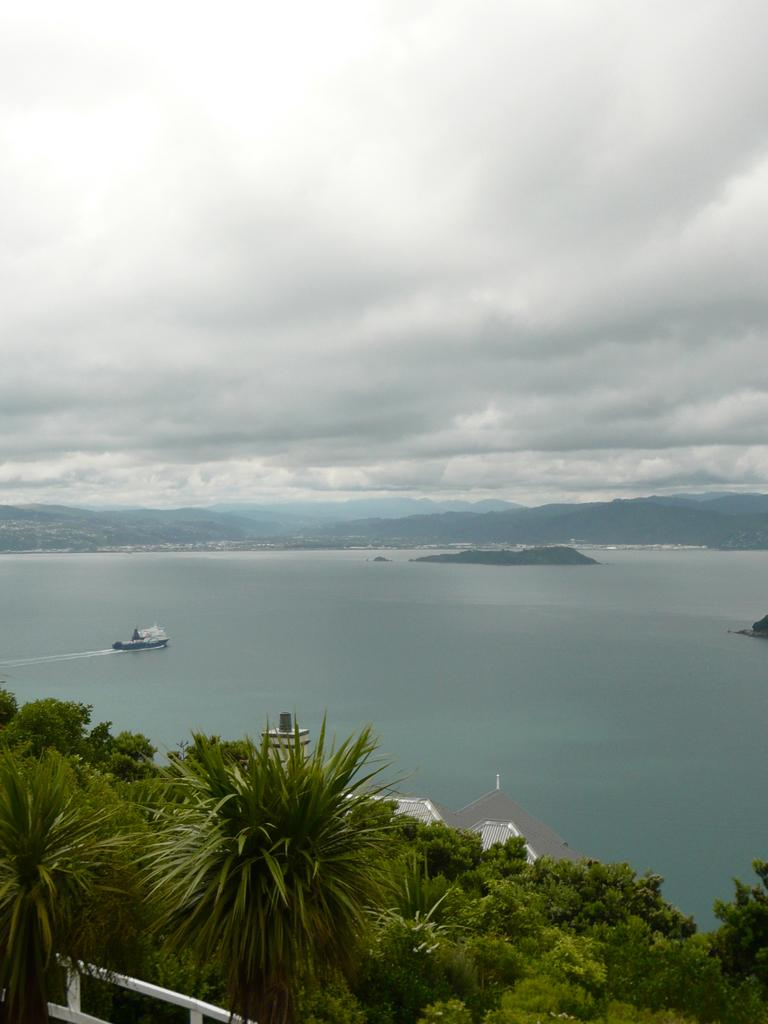What is the main subject of the image? The main subject of the image is a boat. Where is the boat located? The boat is on the water. What other natural elements can be seen in the image? There are trees and mountains visible in the image. What is visible in the background of the image? The sky is visible in the background of the image. Is there a tent set up near the boat in the image? There is no tent present in the image. What type of fruit is being harvested from the trees in the image? There are no fruits mentioned or visible in the image; only trees are present. 